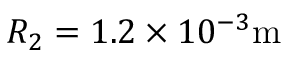<formula> <loc_0><loc_0><loc_500><loc_500>R _ { 2 } = 1 . 2 \times 1 0 ^ { - 3 } m</formula> 